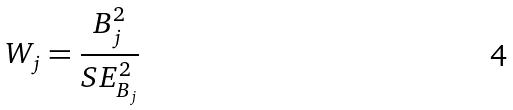<formula> <loc_0><loc_0><loc_500><loc_500>W _ { j } = \frac { B _ { j } ^ { 2 } } { S E _ { B _ { j } } ^ { 2 } }</formula> 